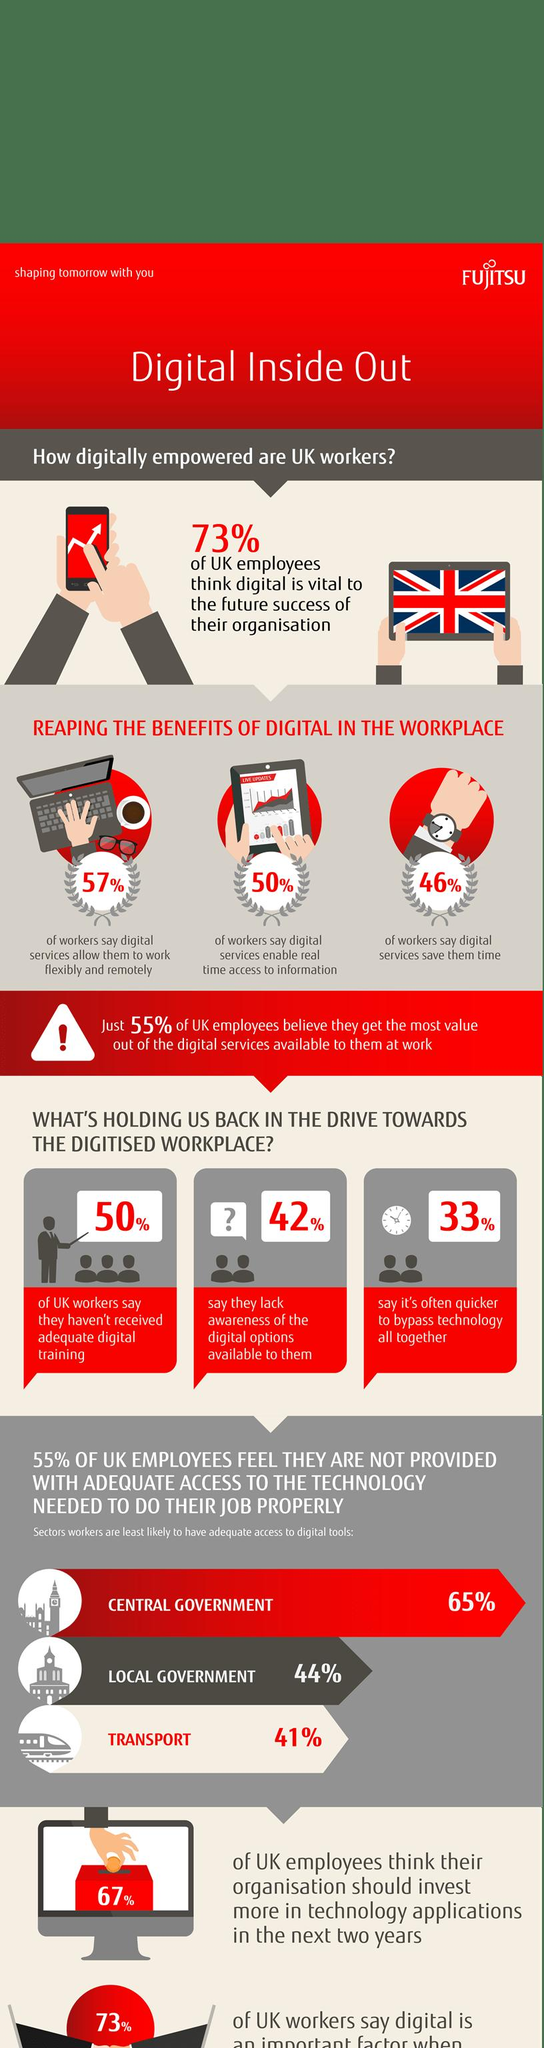Outline some significant characteristics in this image. According to a recent survey of UK workers, 67% believe it is not often quicker to bypass technology altogether. 